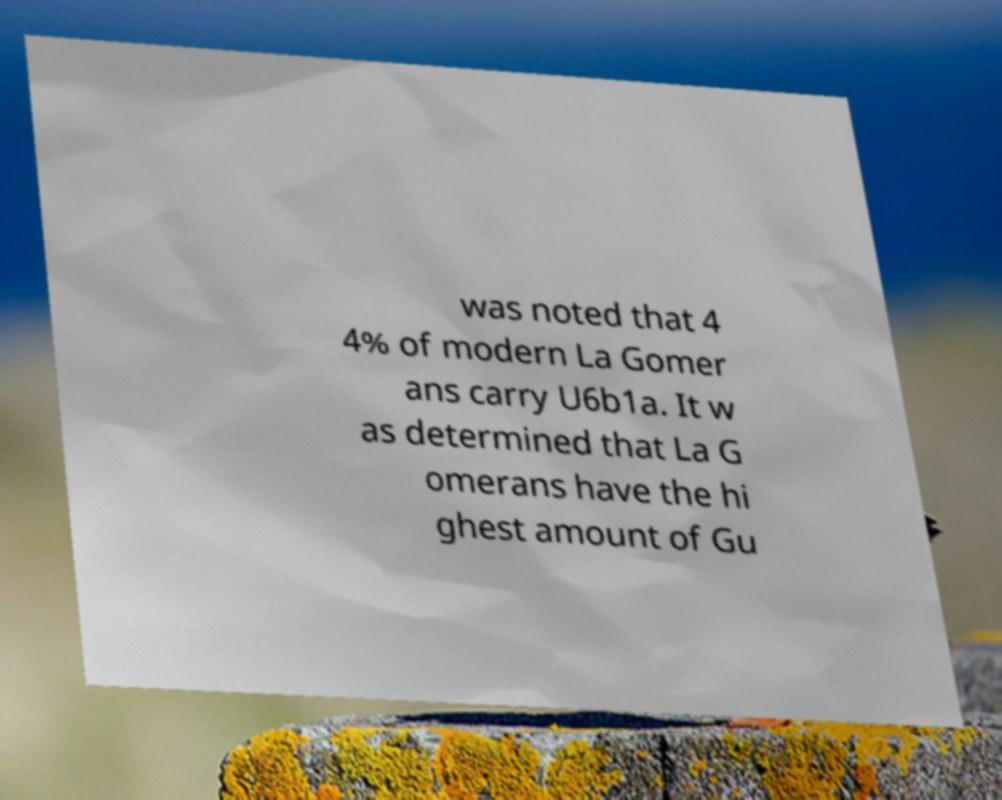Could you assist in decoding the text presented in this image and type it out clearly? was noted that 4 4% of modern La Gomer ans carry U6b1a. It w as determined that La G omerans have the hi ghest amount of Gu 